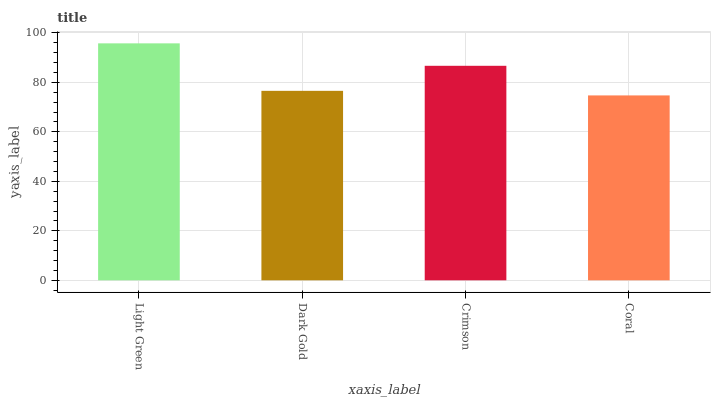Is Coral the minimum?
Answer yes or no. Yes. Is Light Green the maximum?
Answer yes or no. Yes. Is Dark Gold the minimum?
Answer yes or no. No. Is Dark Gold the maximum?
Answer yes or no. No. Is Light Green greater than Dark Gold?
Answer yes or no. Yes. Is Dark Gold less than Light Green?
Answer yes or no. Yes. Is Dark Gold greater than Light Green?
Answer yes or no. No. Is Light Green less than Dark Gold?
Answer yes or no. No. Is Crimson the high median?
Answer yes or no. Yes. Is Dark Gold the low median?
Answer yes or no. Yes. Is Light Green the high median?
Answer yes or no. No. Is Coral the low median?
Answer yes or no. No. 